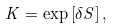Convert formula to latex. <formula><loc_0><loc_0><loc_500><loc_500>K = \exp \left [ \delta S \right ] ,</formula> 